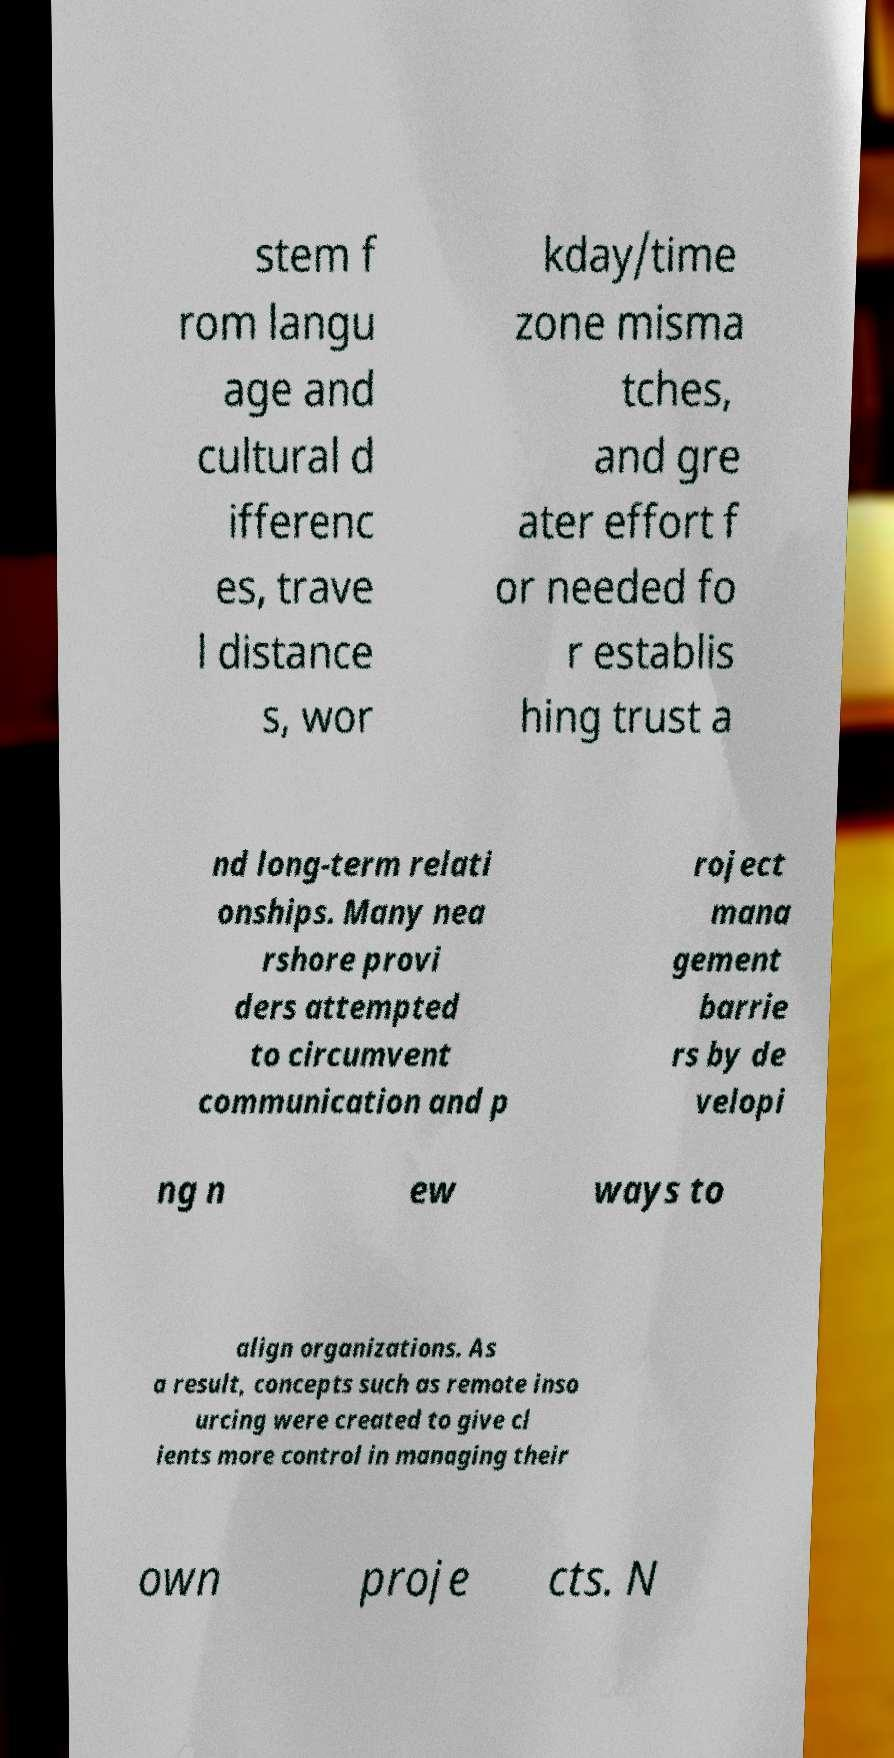Can you accurately transcribe the text from the provided image for me? stem f rom langu age and cultural d ifferenc es, trave l distance s, wor kday/time zone misma tches, and gre ater effort f or needed fo r establis hing trust a nd long-term relati onships. Many nea rshore provi ders attempted to circumvent communication and p roject mana gement barrie rs by de velopi ng n ew ways to align organizations. As a result, concepts such as remote inso urcing were created to give cl ients more control in managing their own proje cts. N 